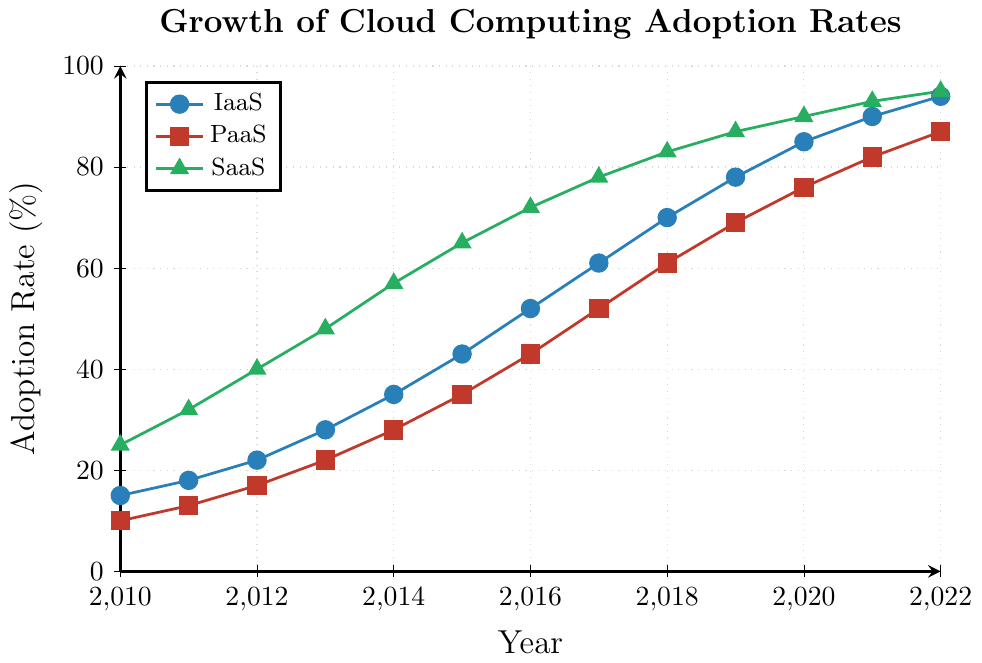What is the adoption rate of SaaS in 2012? Look for the 2012 data point under the SaaS line (represented by green triangles) in the figure. The label shows the adoption rate of 40%.
Answer: 40% Which service type had the highest adoption rate in 2020? Compare the adoption rates of IaaS, PaaS, and SaaS in 2020. SaaS (green triangles) reached 90%, which is higher than IaaS (85%) and PaaS (76%).
Answer: SaaS What is the difference in the adoption rates of IaaS and PaaS in 2017? Find the adoption rates of IaaS (61%) and PaaS (52%) in 2017. The difference is 61% - 52% = 9%.
Answer: 9% Between which two consecutive years did IaaS see the highest growth rate? Calculate the year-over-year growth for IaaS by finding the differences between consecutive years. The highest difference is between 2015 and 2016, where the adoption rate increased from 43% to 52%, i.e., 9%.
Answer: 2015 and 2016 What was the average adoption rate of PaaS from 2010 to 2012? Find the adoption rates of PaaS from 2010 to 2012: 10%, 13%, and 17%. The average is (10% + 13% + 17%) / 3 = 13.33%.
Answer: 13.33% How do the adoption rates of SaaS in 2010 and 2022 compare? Locate the adoption rates of SaaS in 2010 (25%) and 2022 (95%). SaaS grew 70 percentage points over this period.
Answer: 70 percentage points By how much did the adoption rate of PaaS increase from 2011 to 2022? Find the adoption rates of PaaS in 2011 (13%) and 2022 (87%). The increase is 87% - 13% = 74%.
Answer: 74% In which year did all three service types (IaaS, PaaS, and SaaS) cross the 50% adoption rate? Identify the first year in which all lines are above 50%. In 2017, SaaS (78%), IaaS (61%), and PaaS (52%) all exceed 50%.
Answer: 2017 What is the total adoption rate when combining IaaS, PaaS, and SaaS in 2015? Add the adoption rates of IaaS (43%), PaaS (35%), and SaaS (65%) in 2015. The total is 43% + 35% + 65% = 143%.
Answer: 143% Which service type had the slowest growth rate between 2010 and 2022? Calculate the growth rates for IaaS (94% - 15%), PaaS (87% - 10%), and SaaS (95% - 25%). The slowest growth rate is PaaS: 87% - 10% = 77%, which is less than IaaS (79%) and SaaS (70%).
Answer: PaaS 